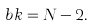Convert formula to latex. <formula><loc_0><loc_0><loc_500><loc_500>b k = N - 2 .</formula> 